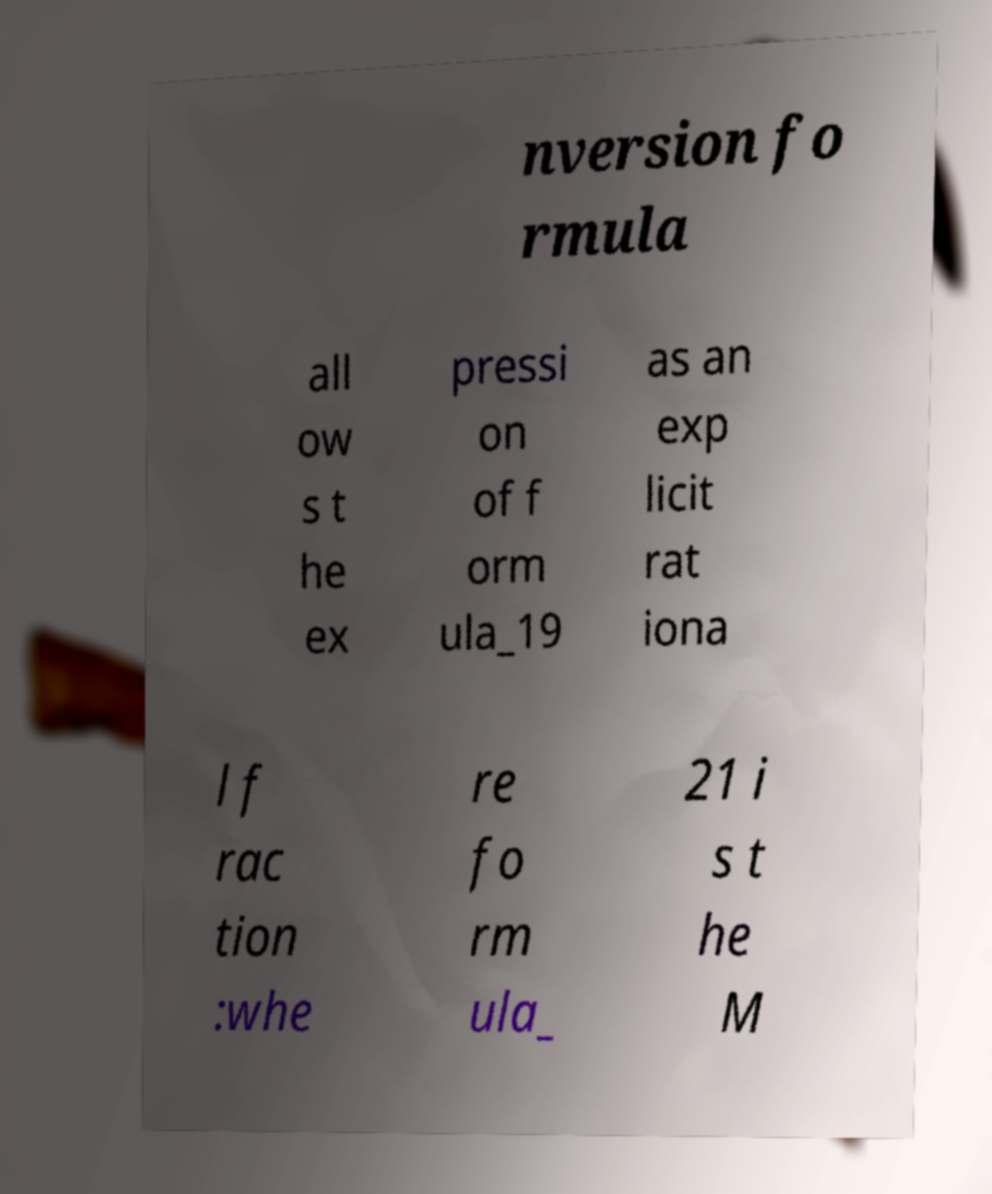Please read and relay the text visible in this image. What does it say? nversion fo rmula all ow s t he ex pressi on of f orm ula_19 as an exp licit rat iona l f rac tion :whe re fo rm ula_ 21 i s t he M 